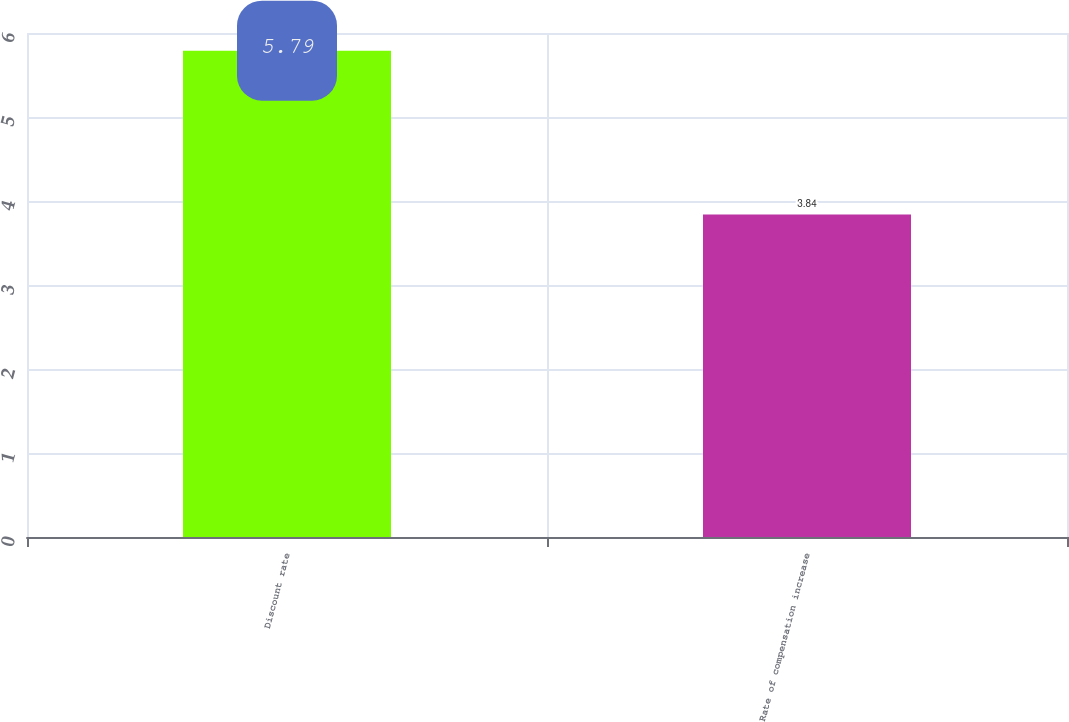Convert chart to OTSL. <chart><loc_0><loc_0><loc_500><loc_500><bar_chart><fcel>Discount rate<fcel>Rate of compensation increase<nl><fcel>5.79<fcel>3.84<nl></chart> 